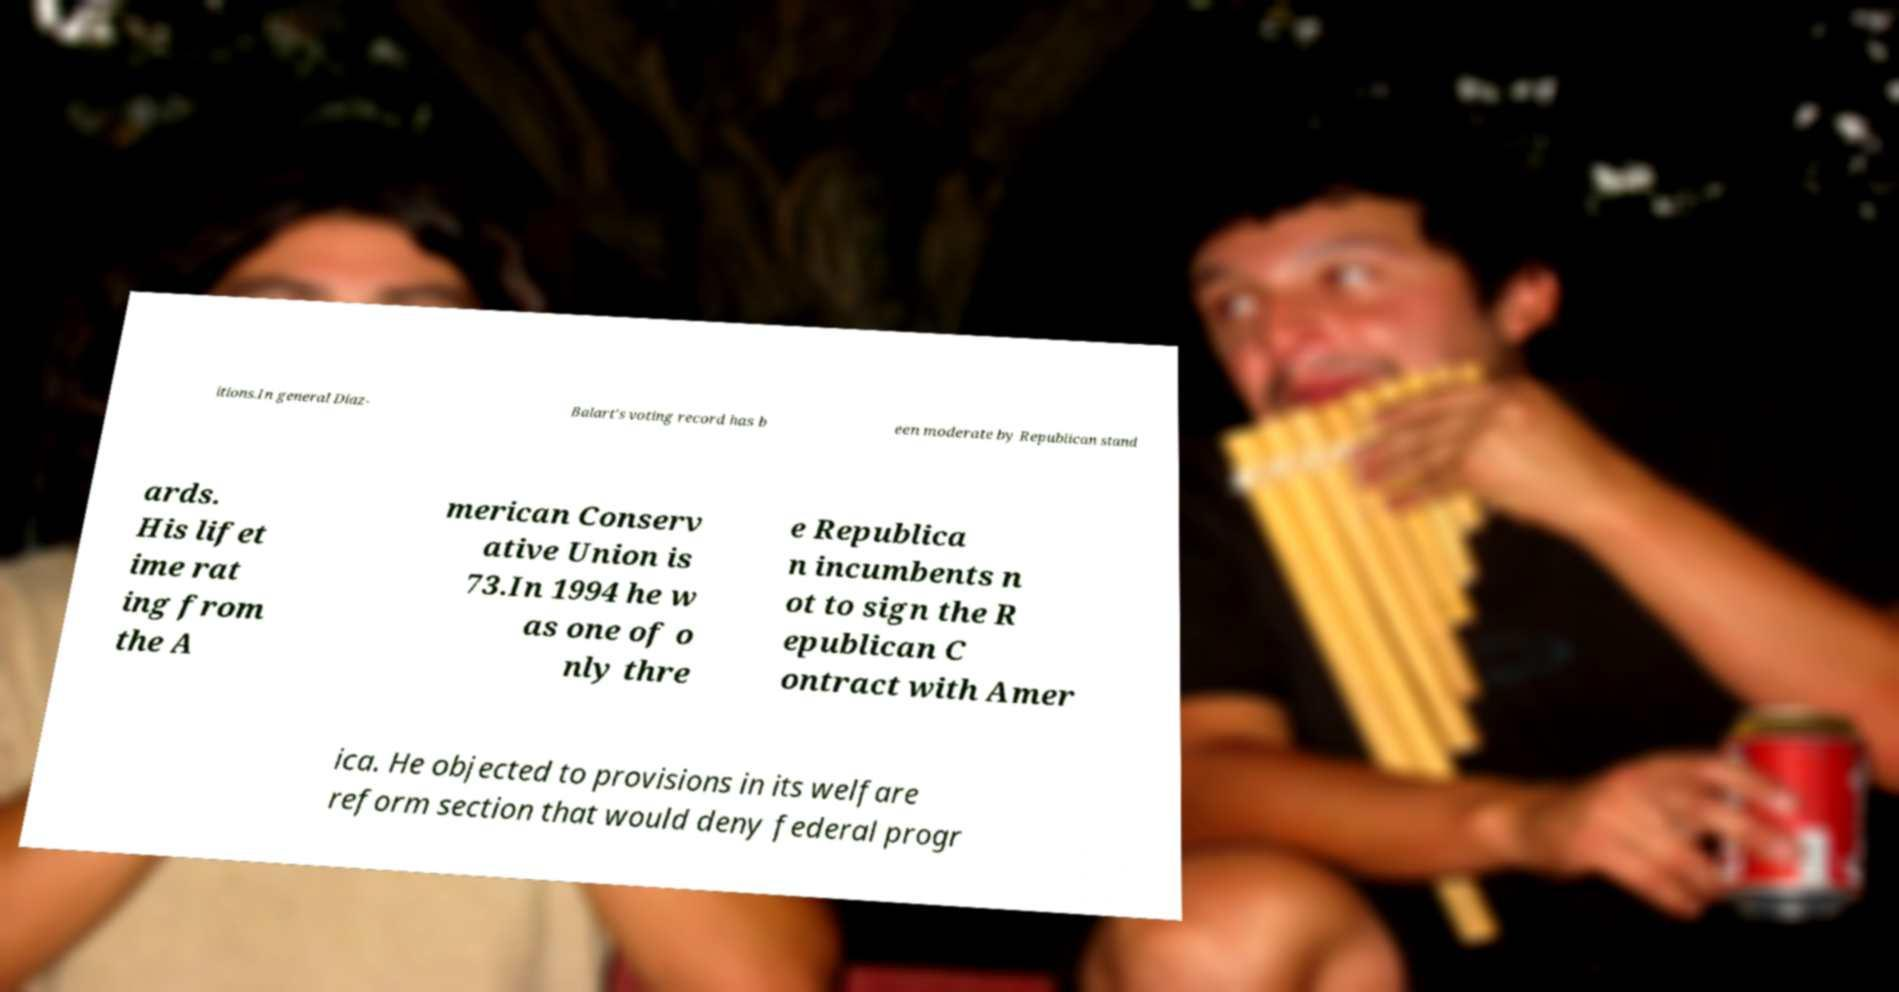Could you extract and type out the text from this image? itions.In general Diaz- Balart's voting record has b een moderate by Republican stand ards. His lifet ime rat ing from the A merican Conserv ative Union is 73.In 1994 he w as one of o nly thre e Republica n incumbents n ot to sign the R epublican C ontract with Amer ica. He objected to provisions in its welfare reform section that would deny federal progr 